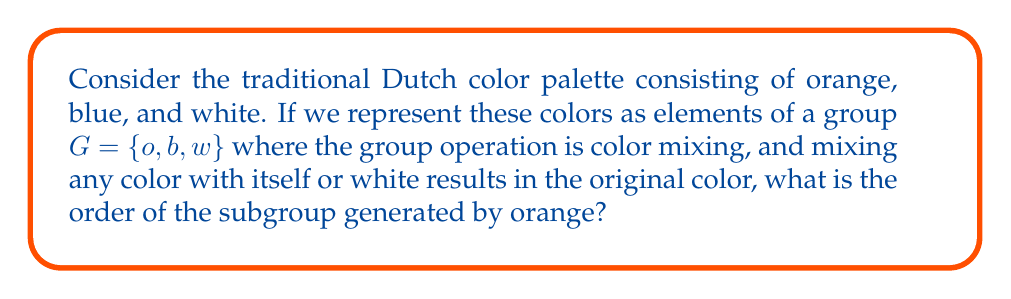What is the answer to this math problem? Let's approach this step-by-step:

1) First, we need to understand the group structure. We have:
   $G = \{o, b, w\}$ where $o$ is orange, $b$ is blue, and $w$ is white.

2) The group operation is color mixing, with the following properties:
   - Mixing any color with itself results in the original color: $x * x = x$ for all $x \in G$
   - Mixing any color with white results in the original color: $x * w = x$ for all $x \in G$
   - White is the identity element: $w * x = x * w = x$ for all $x \in G$

3) To find the subgroup generated by orange, we need to consider all powers of $o$:
   
   $o^1 = o$
   $o^2 = o * o = o$ (by the property of mixing a color with itself)
   $o^3 = o * o * o = o * o = o$
   And so on...

4) We can see that all powers of $o$ result in $o$ itself.

5) Therefore, the subgroup generated by $o$ is $\{o\}$.

6) The order of a subgroup is the number of elements it contains. In this case, the subgroup $\{o\}$ contains only one element.
Answer: The order of the subgroup generated by orange is 1. 